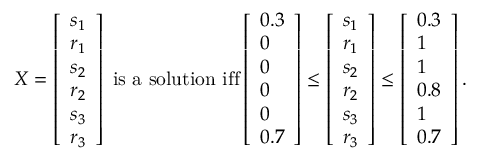<formula> <loc_0><loc_0><loc_500><loc_500>\begin{array} { r } { X = \left [ \begin{array} { l } { s _ { 1 } } \\ { r _ { 1 } } \\ { s _ { 2 } } \\ { r _ { 2 } } \\ { s _ { 3 } } \\ { r _ { 3 } } \end{array} \right ] i s a s o l u t i o n i f f \left [ \begin{array} { l } { 0 . 3 } \\ { 0 } \\ { 0 } \\ { 0 } \\ { 0 } \\ { 0 . 7 } \end{array} \right ] \leq \left [ \begin{array} { l } { s _ { 1 } } \\ { r _ { 1 } } \\ { s _ { 2 } } \\ { r _ { 2 } } \\ { s _ { 3 } } \\ { r _ { 3 } } \end{array} \right ] \leq \left [ \begin{array} { l } { 0 . 3 } \\ { 1 } \\ { 1 } \\ { 0 . 8 } \\ { 1 } \\ { 0 . 7 } \end{array} \right ] . } \end{array}</formula> 